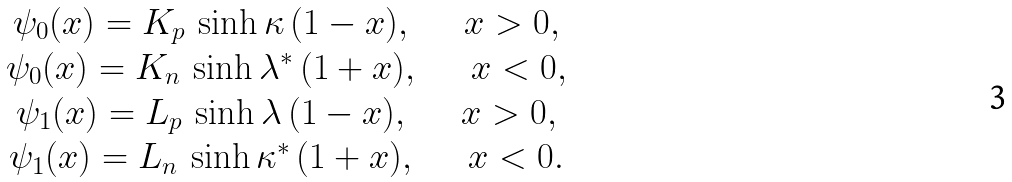Convert formula to latex. <formula><loc_0><loc_0><loc_500><loc_500>\begin{array} { c } \psi _ { 0 } ( x ) = K _ { p } \, \sinh \kappa \, ( 1 - x ) , \quad \ \ x > 0 , \\ \psi _ { 0 } ( x ) = K _ { n } \, \sinh \lambda ^ { * } \, ( 1 + x ) , \quad \ \ x < 0 , \\ \psi _ { 1 } ( x ) = L _ { p } \, \sinh \lambda \, ( 1 - x ) , \quad \ \ x > 0 , \\ \psi _ { 1 } ( x ) = L _ { n } \, \sinh \kappa ^ { * } \, ( 1 + x ) , \quad \ \ x < 0 . \end{array}</formula> 